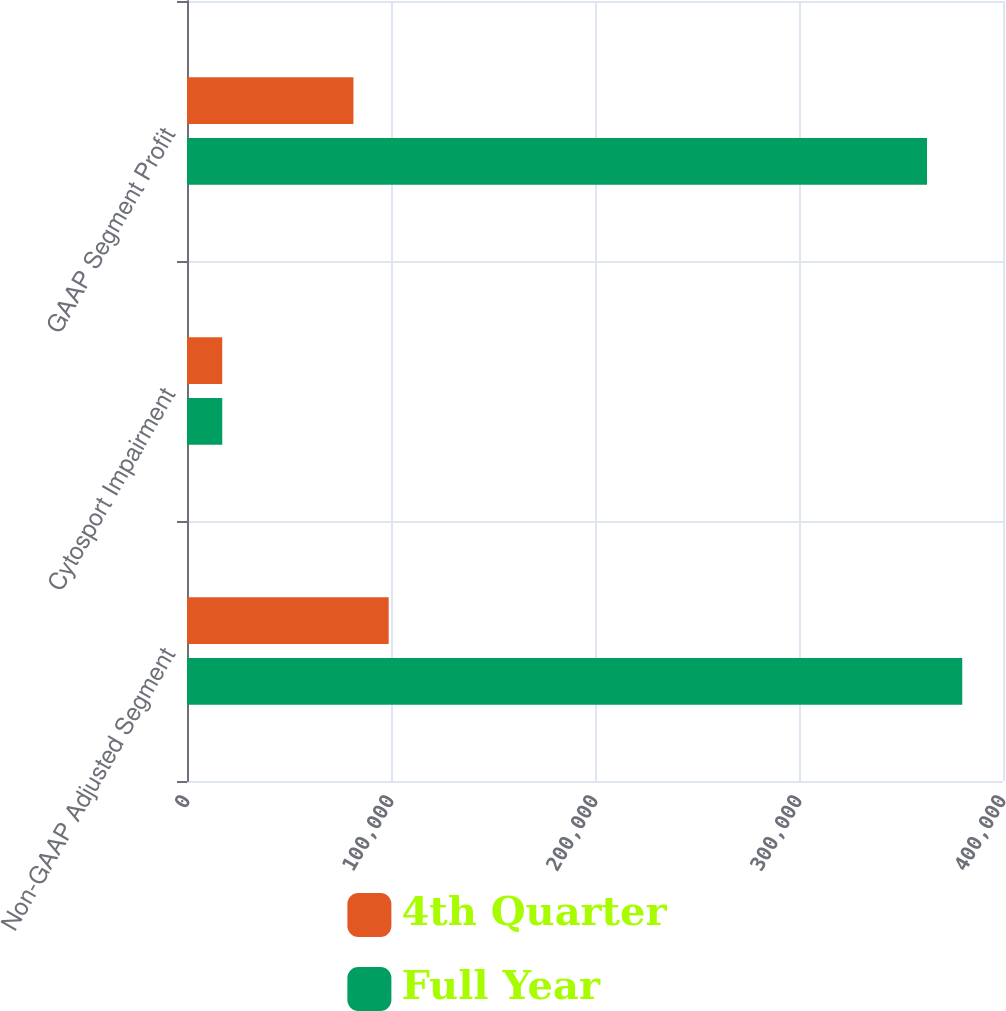Convert chart to OTSL. <chart><loc_0><loc_0><loc_500><loc_500><stacked_bar_chart><ecel><fcel>Non-GAAP Adjusted Segment<fcel>Cytosport Impairment<fcel>GAAP Segment Profit<nl><fcel>4th Quarter<fcel>98861<fcel>17279<fcel>81582<nl><fcel>Full Year<fcel>380029<fcel>17279<fcel>362750<nl></chart> 